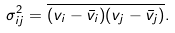<formula> <loc_0><loc_0><loc_500><loc_500>\sigma ^ { 2 } _ { i j } = \overline { ( v _ { i } - { \bar { v } _ { i } } ) ( v _ { j } - { \bar { v } _ { j } } ) } .</formula> 